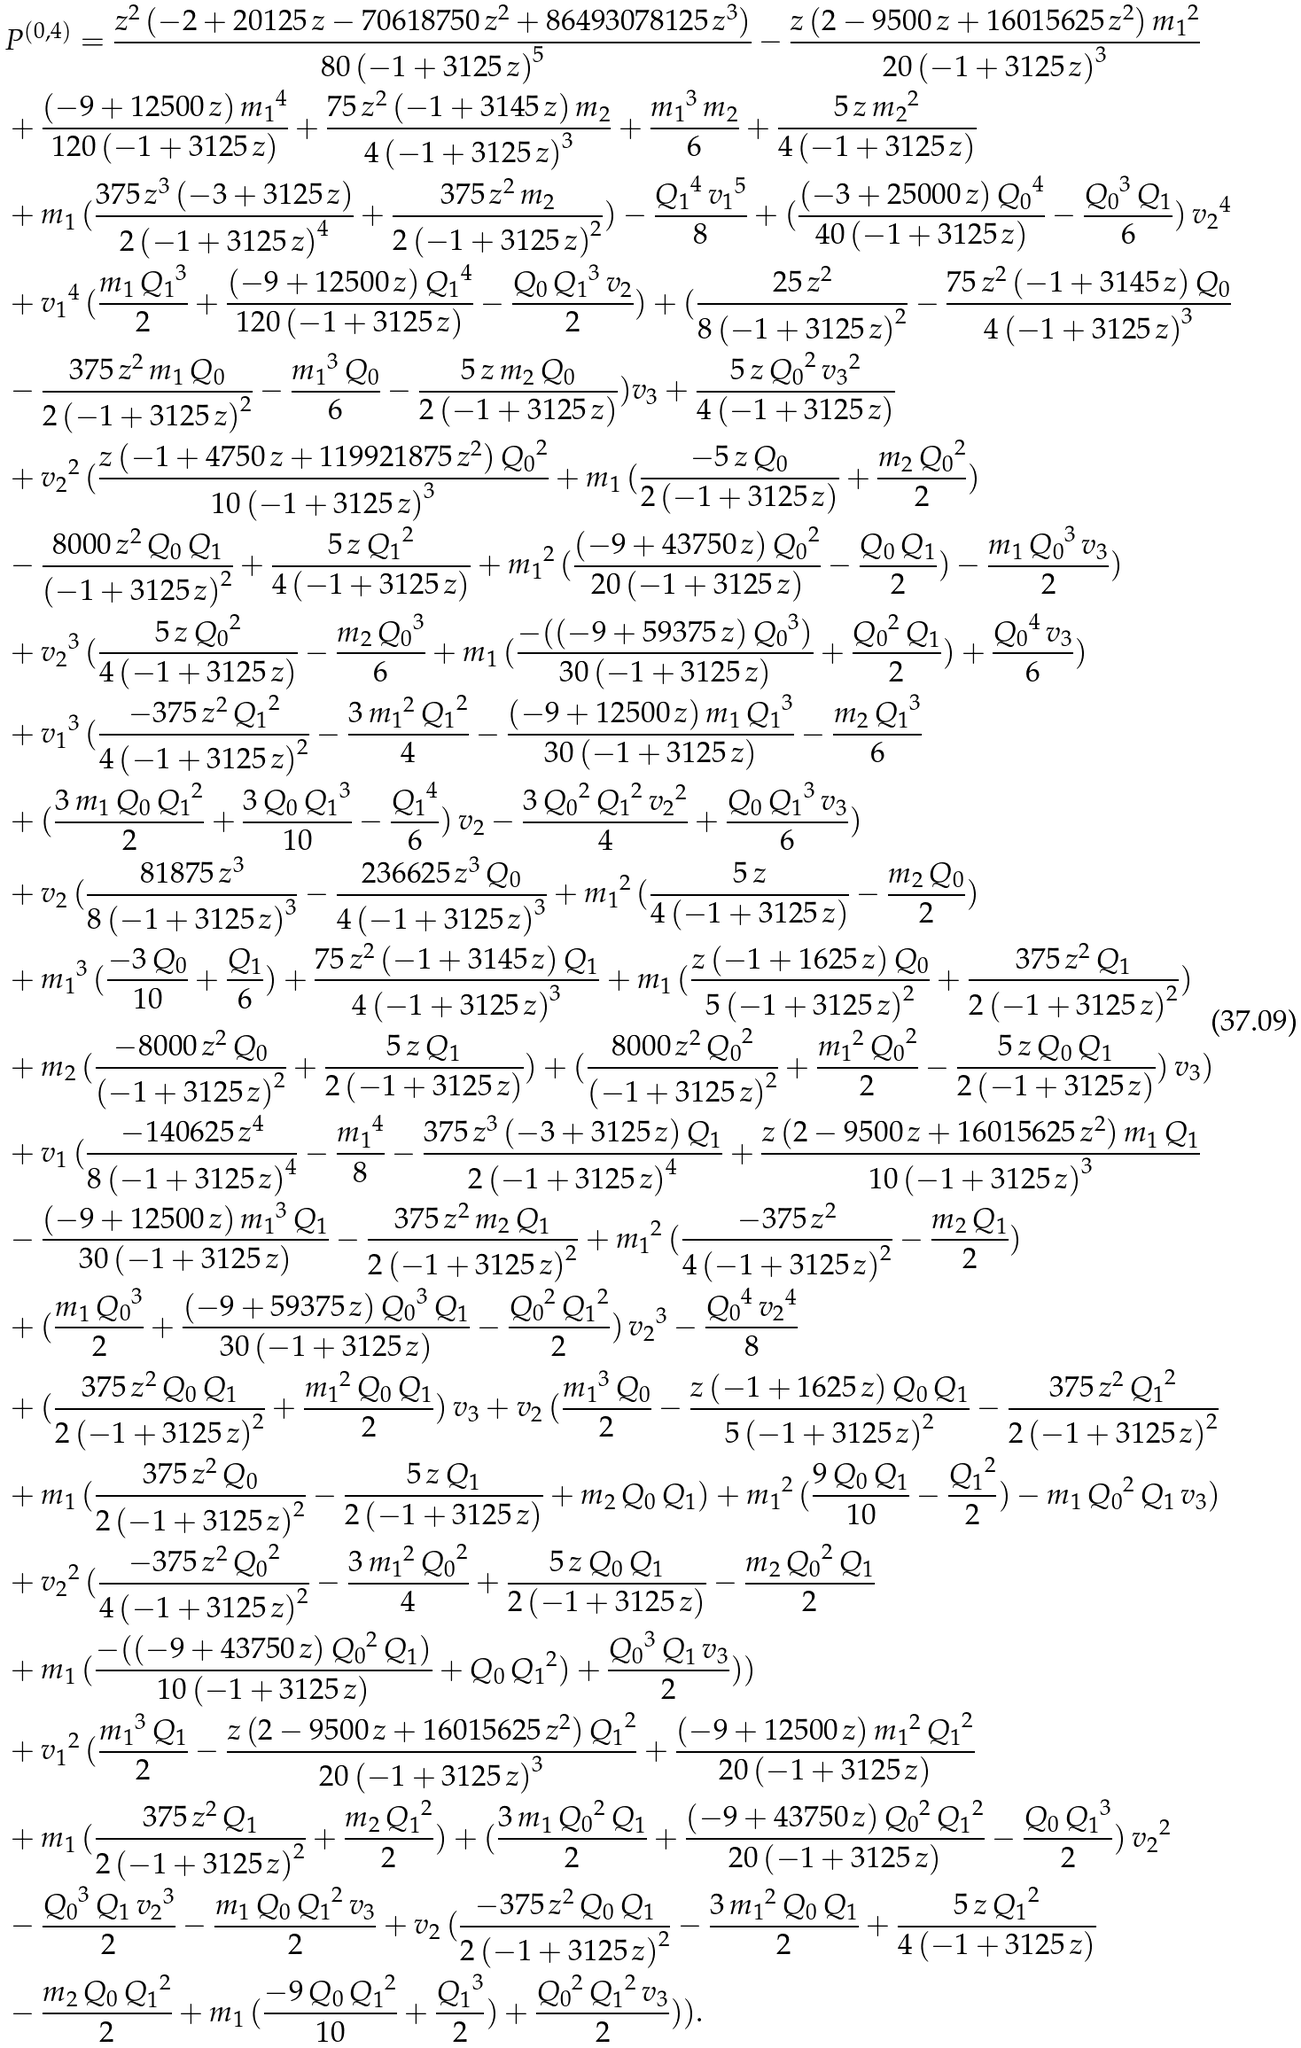Convert formula to latex. <formula><loc_0><loc_0><loc_500><loc_500>& P ^ { ( 0 , 4 ) } = \frac { z ^ { 2 } \, ( - 2 + 2 0 1 2 5 \, z - 7 0 6 1 8 7 5 0 \, z ^ { 2 } + 8 6 4 9 3 0 7 8 1 2 5 \, z ^ { 3 } ) } { 8 0 \, { ( - 1 + 3 1 2 5 \, z ) } ^ { 5 } } - \frac { z \, ( 2 - 9 5 0 0 \, z + 1 6 0 1 5 6 2 5 \, z ^ { 2 } ) \, { m _ { 1 } } ^ { 2 } } { 2 0 \, { ( - 1 + 3 1 2 5 \, z ) } ^ { 3 } } \\ & + \frac { ( - 9 + 1 2 5 0 0 \, z ) \, { m _ { 1 } } ^ { 4 } } { 1 2 0 \, ( - 1 + 3 1 2 5 \, z ) } + \frac { 7 5 \, z ^ { 2 } \, ( - 1 + 3 1 4 5 \, z ) \, m _ { 2 } } { 4 \, { ( - 1 + 3 1 2 5 \, z ) } ^ { 3 } } + \frac { { m _ { 1 } } ^ { 3 } \, m _ { 2 } } { 6 } + \frac { 5 \, z \, { m _ { 2 } } ^ { 2 } } { 4 \, ( - 1 + 3 1 2 5 \, z ) } \\ & + m _ { 1 } \, ( \frac { 3 7 5 \, z ^ { 3 } \, ( - 3 + 3 1 2 5 \, z ) } { 2 \, { ( - 1 + 3 1 2 5 \, z ) } ^ { 4 } } + \frac { 3 7 5 \, z ^ { 2 } \, m _ { 2 } } { 2 \, { ( - 1 + 3 1 2 5 \, z ) } ^ { 2 } } ) - \frac { { Q _ { 1 } } ^ { 4 } \, { v _ { 1 } } ^ { 5 } } { 8 } + ( \frac { ( - 3 + 2 5 0 0 0 \, z ) \, { Q _ { 0 } } ^ { 4 } } { 4 0 \, ( - 1 + 3 1 2 5 \, z ) } - \frac { { Q _ { 0 } } ^ { 3 } \, Q _ { 1 } } { 6 } ) \, { v _ { 2 } } ^ { 4 } \\ & + { v _ { 1 } } ^ { 4 } \, ( \frac { m _ { 1 } \, { Q _ { 1 } } ^ { 3 } } { 2 } + \frac { ( - 9 + 1 2 5 0 0 \, z ) \, { Q _ { 1 } } ^ { 4 } } { 1 2 0 \, ( - 1 + 3 1 2 5 \, z ) } - \frac { Q _ { 0 } \, { Q _ { 1 } } ^ { 3 } \, v _ { 2 } } { 2 } ) + ( \frac { 2 5 \, z ^ { 2 } } { 8 \, { ( - 1 + 3 1 2 5 \, z ) } ^ { 2 } } - \frac { 7 5 \, z ^ { 2 } \, ( - 1 + 3 1 4 5 \, z ) \, Q _ { 0 } } { 4 \, { ( - 1 + 3 1 2 5 \, z ) } ^ { 3 } } \\ & - \frac { 3 7 5 \, z ^ { 2 } \, m _ { 1 } \, Q _ { 0 } } { 2 \, { ( - 1 + 3 1 2 5 \, z ) } ^ { 2 } } - \frac { { m _ { 1 } } ^ { 3 } \, Q _ { 0 } } { 6 } - \frac { 5 \, z \, m _ { 2 } \, Q _ { 0 } } { 2 \, ( - 1 + 3 1 2 5 \, z ) } ) v _ { 3 } + \frac { 5 \, z \, { Q _ { 0 } } ^ { 2 } \, { v _ { 3 } } ^ { 2 } } { 4 \, ( - 1 + 3 1 2 5 \, z ) } \\ & + { v _ { 2 } } ^ { 2 } \, ( \frac { z \, ( - 1 + 4 7 5 0 \, z + 1 1 9 9 2 1 8 7 5 \, z ^ { 2 } ) \, { Q _ { 0 } } ^ { 2 } } { 1 0 \, { ( - 1 + 3 1 2 5 \, z ) } ^ { 3 } } + m _ { 1 } \, ( \frac { - 5 \, z \, Q _ { 0 } } { 2 \, ( - 1 + 3 1 2 5 \, z ) } + \frac { m _ { 2 } \, { Q _ { 0 } } ^ { 2 } } { 2 } ) \\ & - \frac { 8 0 0 0 \, z ^ { 2 } \, Q _ { 0 } \, Q _ { 1 } } { { ( - 1 + 3 1 2 5 \, z ) } ^ { 2 } } + \frac { 5 \, z \, { Q _ { 1 } } ^ { 2 } } { 4 \, ( - 1 + 3 1 2 5 \, z ) } + { m _ { 1 } } ^ { 2 } \, ( \frac { ( - 9 + 4 3 7 5 0 \, z ) \, { Q _ { 0 } } ^ { 2 } } { 2 0 \, ( - 1 + 3 1 2 5 \, z ) } - \frac { Q _ { 0 } \, Q _ { 1 } } { 2 } ) - \frac { m _ { 1 } \, { Q _ { 0 } } ^ { 3 } \, v _ { 3 } } { 2 } ) \\ & + { v _ { 2 } } ^ { 3 } \, ( \frac { 5 \, z \, { Q _ { 0 } } ^ { 2 } } { 4 \, ( - 1 + 3 1 2 5 \, z ) } - \frac { m _ { 2 } \, { Q _ { 0 } } ^ { 3 } } { 6 } + m _ { 1 } \, ( \frac { - ( ( - 9 + 5 9 3 7 5 \, z ) \, { Q _ { 0 } } ^ { 3 } ) } { 3 0 \, ( - 1 + 3 1 2 5 \, z ) } + \frac { { Q _ { 0 } } ^ { 2 } \, Q _ { 1 } } { 2 } ) + \frac { { Q _ { 0 } } ^ { 4 } \, v _ { 3 } } { 6 } ) \\ & + { v _ { 1 } } ^ { 3 } \, ( \frac { - 3 7 5 \, z ^ { 2 } \, { Q _ { 1 } } ^ { 2 } } { 4 \, { ( - 1 + 3 1 2 5 \, z ) } ^ { 2 } } - \frac { 3 \, { m _ { 1 } } ^ { 2 } \, { Q _ { 1 } } ^ { 2 } } { 4 } - \frac { ( - 9 + 1 2 5 0 0 \, z ) \, m _ { 1 } \, { Q _ { 1 } } ^ { 3 } } { 3 0 \, ( - 1 + 3 1 2 5 \, z ) } - \frac { m _ { 2 } \, { Q _ { 1 } } ^ { 3 } } { 6 } \\ & + ( \frac { 3 \, m _ { 1 } \, Q _ { 0 } \, { Q _ { 1 } } ^ { 2 } } { 2 } + \frac { 3 \, Q _ { 0 } \, { Q _ { 1 } } ^ { 3 } } { 1 0 } - \frac { { Q _ { 1 } } ^ { 4 } } { 6 } ) \, v _ { 2 } - \frac { 3 \, { Q _ { 0 } } ^ { 2 } \, { Q _ { 1 } } ^ { 2 } \, { v _ { 2 } } ^ { 2 } } { 4 } + \frac { Q _ { 0 } \, { Q _ { 1 } } ^ { 3 } \, v _ { 3 } } { 6 } ) \\ & + v _ { 2 } \, ( \frac { 8 1 8 7 5 \, z ^ { 3 } } { 8 \, { ( - 1 + 3 1 2 5 \, z ) } ^ { 3 } } - \frac { 2 3 6 6 2 5 \, z ^ { 3 } \, Q _ { 0 } } { 4 \, { ( - 1 + 3 1 2 5 \, z ) } ^ { 3 } } + { m _ { 1 } } ^ { 2 } \, ( \frac { 5 \, z } { 4 \, ( - 1 + 3 1 2 5 \, z ) } - \frac { m _ { 2 } \, Q _ { 0 } } { 2 } ) \\ & + { m _ { 1 } } ^ { 3 } \, ( \frac { - 3 \, Q _ { 0 } } { 1 0 } + \frac { Q _ { 1 } } { 6 } ) + \frac { 7 5 \, z ^ { 2 } \, ( - 1 + 3 1 4 5 \, z ) \, Q _ { 1 } } { 4 \, { ( - 1 + 3 1 2 5 \, z ) } ^ { 3 } } + m _ { 1 } \, ( \frac { z \, ( - 1 + 1 6 2 5 \, z ) \, Q _ { 0 } } { 5 \, { ( - 1 + 3 1 2 5 \, z ) } ^ { 2 } } + \frac { 3 7 5 \, z ^ { 2 } \, Q _ { 1 } } { 2 \, { ( - 1 + 3 1 2 5 \, z ) } ^ { 2 } } ) \\ & + m _ { 2 } \, ( \frac { - 8 0 0 0 \, z ^ { 2 } \, Q _ { 0 } } { { ( - 1 + 3 1 2 5 \, z ) } ^ { 2 } } + \frac { 5 \, z \, Q _ { 1 } } { 2 \, ( - 1 + 3 1 2 5 \, z ) } ) + ( \frac { 8 0 0 0 \, z ^ { 2 } \, { Q _ { 0 } } ^ { 2 } } { { ( - 1 + 3 1 2 5 \, z ) } ^ { 2 } } + \frac { { m _ { 1 } } ^ { 2 } \, { Q _ { 0 } } ^ { 2 } } { 2 } - \frac { 5 \, z \, Q _ { 0 } \, Q _ { 1 } } { 2 \, ( - 1 + 3 1 2 5 \, z ) } ) \, v _ { 3 } ) \\ & + v _ { 1 } \, ( \frac { - 1 4 0 6 2 5 \, z ^ { 4 } } { 8 \, { ( - 1 + 3 1 2 5 \, z ) } ^ { 4 } } - \frac { { m _ { 1 } } ^ { 4 } } { 8 } - \frac { 3 7 5 \, z ^ { 3 } \, ( - 3 + 3 1 2 5 \, z ) \, Q _ { 1 } } { 2 \, { ( - 1 + 3 1 2 5 \, z ) } ^ { 4 } } + \frac { z \, ( 2 - 9 5 0 0 \, z + 1 6 0 1 5 6 2 5 \, z ^ { 2 } ) \, m _ { 1 } \, Q _ { 1 } } { 1 0 \, { ( - 1 + 3 1 2 5 \, z ) } ^ { 3 } } \\ & - \frac { ( - 9 + 1 2 5 0 0 \, z ) \, { m _ { 1 } } ^ { 3 } \, Q _ { 1 } } { 3 0 \, ( - 1 + 3 1 2 5 \, z ) } - \frac { 3 7 5 \, z ^ { 2 } \, m _ { 2 } \, Q _ { 1 } } { 2 \, { ( - 1 + 3 1 2 5 \, z ) } ^ { 2 } } + { m _ { 1 } } ^ { 2 } \, ( \frac { - 3 7 5 \, z ^ { 2 } } { 4 \, { ( - 1 + 3 1 2 5 \, z ) } ^ { 2 } } - \frac { m _ { 2 } \, Q _ { 1 } } { 2 } ) \\ & + ( \frac { m _ { 1 } \, { Q _ { 0 } } ^ { 3 } } { 2 } + \frac { ( - 9 + 5 9 3 7 5 \, z ) \, { Q _ { 0 } } ^ { 3 } \, Q _ { 1 } } { 3 0 \, ( - 1 + 3 1 2 5 \, z ) } - \frac { { Q _ { 0 } } ^ { 2 } \, { Q _ { 1 } } ^ { 2 } } { 2 } ) \, { v _ { 2 } } ^ { 3 } - \frac { { Q _ { 0 } } ^ { 4 } \, { v _ { 2 } } ^ { 4 } } { 8 } \\ & + ( \frac { 3 7 5 \, z ^ { 2 } \, Q _ { 0 } \, Q _ { 1 } } { 2 \, { ( - 1 + 3 1 2 5 \, z ) } ^ { 2 } } + \frac { { m _ { 1 } } ^ { 2 } \, Q _ { 0 } \, Q _ { 1 } } { 2 } ) \, v _ { 3 } + v _ { 2 } \, ( \frac { { m _ { 1 } } ^ { 3 } \, Q _ { 0 } } { 2 } - \frac { z \, ( - 1 + 1 6 2 5 \, z ) \, Q _ { 0 } \, Q _ { 1 } } { 5 \, { ( - 1 + 3 1 2 5 \, z ) } ^ { 2 } } - \frac { 3 7 5 \, z ^ { 2 } \, { Q _ { 1 } } ^ { 2 } } { 2 \, { ( - 1 + 3 1 2 5 \, z ) } ^ { 2 } } \\ & + m _ { 1 } \, ( \frac { 3 7 5 \, z ^ { 2 } \, Q _ { 0 } } { 2 \, { ( - 1 + 3 1 2 5 \, z ) } ^ { 2 } } - \frac { 5 \, z \, Q _ { 1 } } { 2 \, ( - 1 + 3 1 2 5 \, z ) } + m _ { 2 } \, Q _ { 0 } \, Q _ { 1 } ) + { m _ { 1 } } ^ { 2 } \, ( \frac { 9 \, Q _ { 0 } \, Q _ { 1 } } { 1 0 } - \frac { { Q _ { 1 } } ^ { 2 } } { 2 } ) - m _ { 1 } \, { Q _ { 0 } } ^ { 2 } \, Q _ { 1 } \, v _ { 3 } ) \\ & + { v _ { 2 } } ^ { 2 } \, ( \frac { - 3 7 5 \, z ^ { 2 } \, { Q _ { 0 } } ^ { 2 } } { 4 \, { ( - 1 + 3 1 2 5 \, z ) } ^ { 2 } } - \frac { 3 \, { m _ { 1 } } ^ { 2 } \, { Q _ { 0 } } ^ { 2 } } { 4 } + \frac { 5 \, z \, Q _ { 0 } \, Q _ { 1 } } { 2 \, ( - 1 + 3 1 2 5 \, z ) } - \frac { m _ { 2 } \, { Q _ { 0 } } ^ { 2 } \, Q _ { 1 } } { 2 } \\ & + m _ { 1 } \, ( \frac { - ( ( - 9 + 4 3 7 5 0 \, z ) \, { Q _ { 0 } } ^ { 2 } \, Q _ { 1 } ) } { 1 0 \, ( - 1 + 3 1 2 5 \, z ) } + Q _ { 0 } \, { Q _ { 1 } } ^ { 2 } ) + \frac { { Q _ { 0 } } ^ { 3 } \, Q _ { 1 } \, v _ { 3 } } { 2 } ) ) \\ & + { v _ { 1 } } ^ { 2 } \, ( \frac { { m _ { 1 } } ^ { 3 } \, Q _ { 1 } } { 2 } - \frac { z \, ( 2 - 9 5 0 0 \, z + 1 6 0 1 5 6 2 5 \, z ^ { 2 } ) \, { Q _ { 1 } } ^ { 2 } } { 2 0 \, { ( - 1 + 3 1 2 5 \, z ) } ^ { 3 } } + \frac { ( - 9 + 1 2 5 0 0 \, z ) \, { m _ { 1 } } ^ { 2 } \, { Q _ { 1 } } ^ { 2 } } { 2 0 \, ( - 1 + 3 1 2 5 \, z ) } \\ & + m _ { 1 } \, ( \frac { 3 7 5 \, z ^ { 2 } \, Q _ { 1 } } { 2 \, { ( - 1 + 3 1 2 5 \, z ) } ^ { 2 } } + \frac { m _ { 2 } \, { Q _ { 1 } } ^ { 2 } } { 2 } ) + ( \frac { 3 \, m _ { 1 } \, { Q _ { 0 } } ^ { 2 } \, Q _ { 1 } } { 2 } + \frac { ( - 9 + 4 3 7 5 0 \, z ) \, { Q _ { 0 } } ^ { 2 } \, { Q _ { 1 } } ^ { 2 } } { 2 0 \, ( - 1 + 3 1 2 5 \, z ) } - \frac { Q _ { 0 } \, { Q _ { 1 } } ^ { 3 } } { 2 } ) \, { v _ { 2 } } ^ { 2 } \\ & - \frac { { Q _ { 0 } } ^ { 3 } \, Q _ { 1 } \, { v _ { 2 } } ^ { 3 } } { 2 } - \frac { m _ { 1 } \, Q _ { 0 } \, { Q _ { 1 } } ^ { 2 } \, v _ { 3 } } { 2 } + v _ { 2 } \, ( \frac { - 3 7 5 \, z ^ { 2 } \, Q _ { 0 } \, Q _ { 1 } } { 2 \, { ( - 1 + 3 1 2 5 \, z ) } ^ { 2 } } - \frac { 3 \, { m _ { 1 } } ^ { 2 } \, Q _ { 0 } \, Q _ { 1 } } { 2 } + \frac { 5 \, z \, { Q _ { 1 } } ^ { 2 } } { 4 \, ( - 1 + 3 1 2 5 \, z ) } \\ & - \frac { m _ { 2 } \, Q _ { 0 } \, { Q _ { 1 } } ^ { 2 } } { 2 } + m _ { 1 } \, ( \frac { - 9 \, Q _ { 0 } \, { Q _ { 1 } } ^ { 2 } } { 1 0 } + \frac { { Q _ { 1 } } ^ { 3 } } { 2 } ) + \frac { { Q _ { 0 } } ^ { 2 } \, { Q _ { 1 } } ^ { 2 } \, v _ { 3 } } { 2 } ) ) .</formula> 